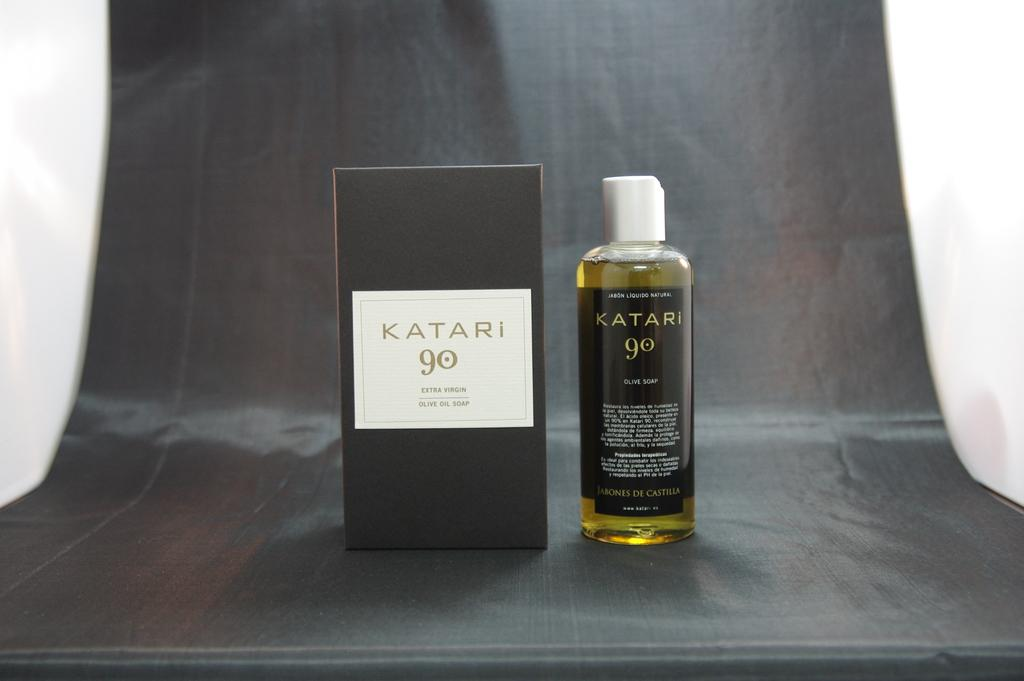<image>
Render a clear and concise summary of the photo. a bottle of liquid soap made from olive oil named katari go 